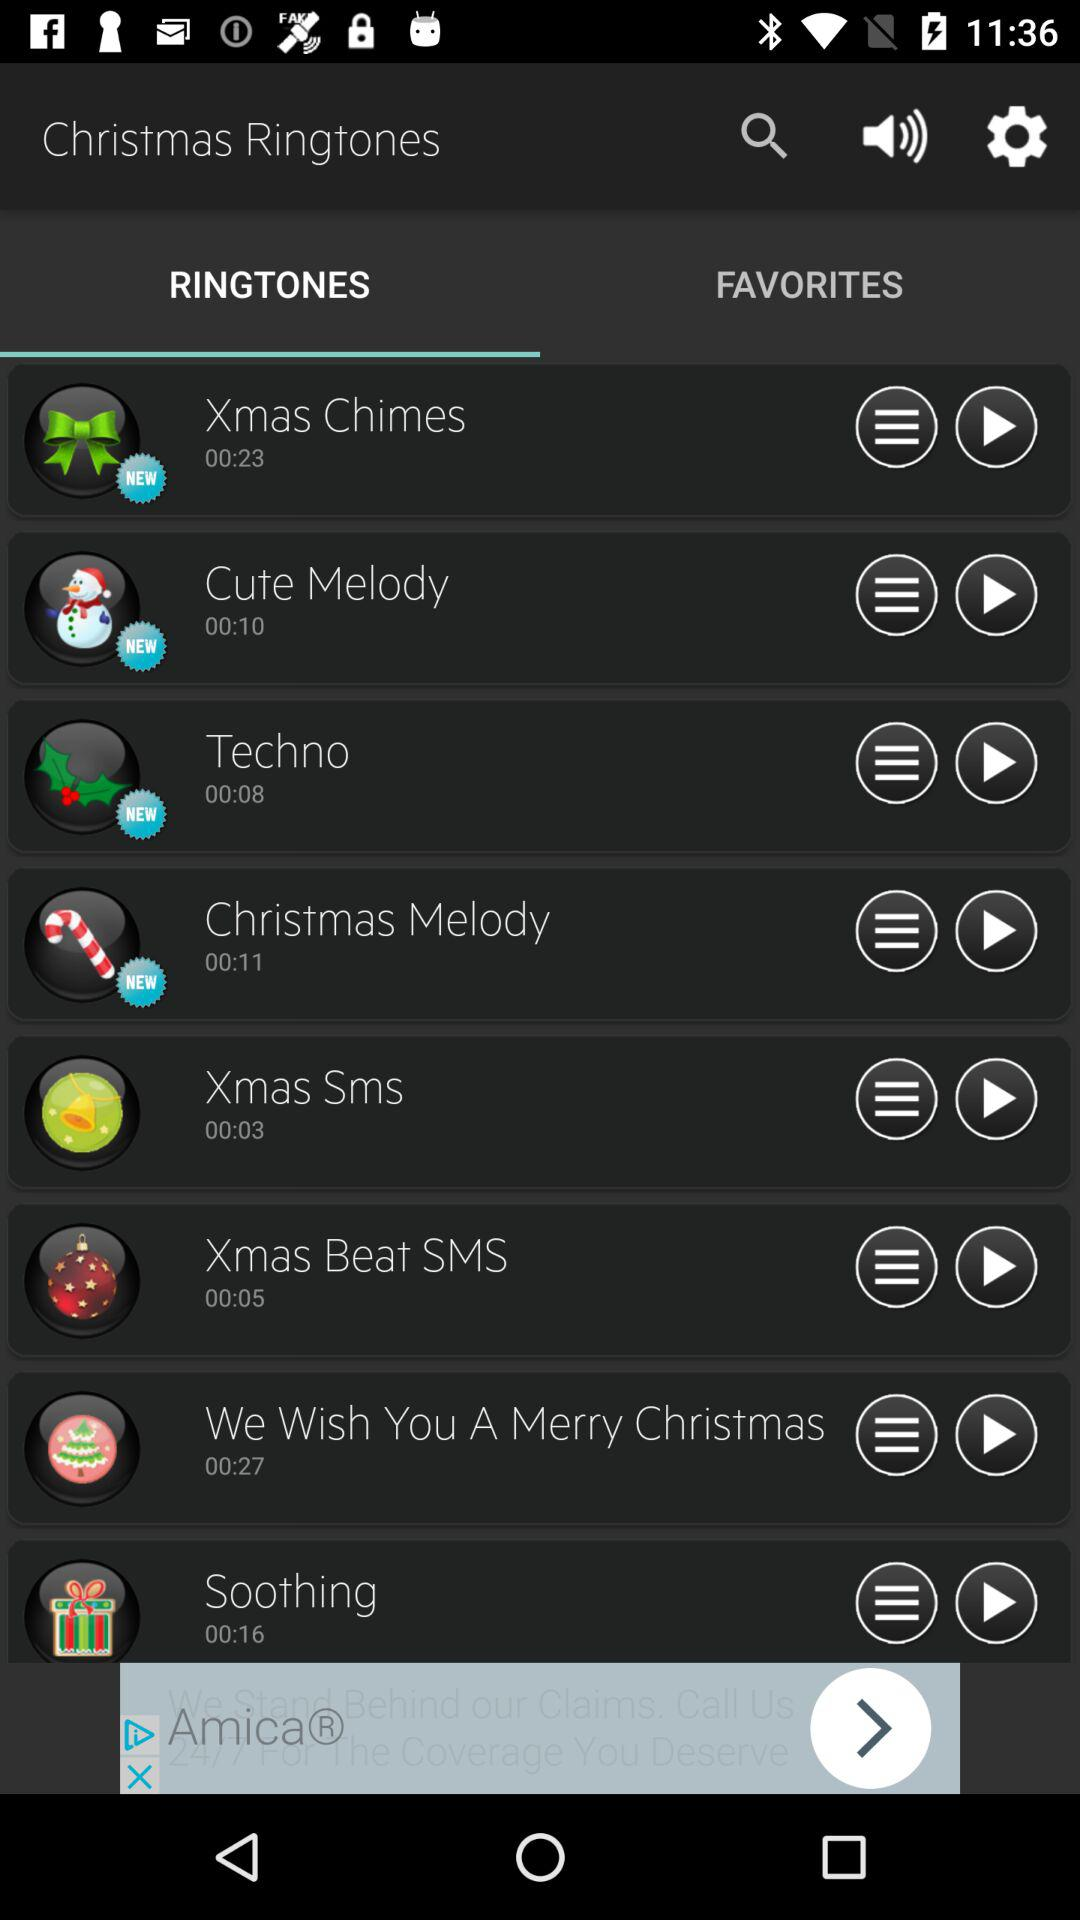What is the duration of "Cute Melody" ringtone? The duration is 00:10. 